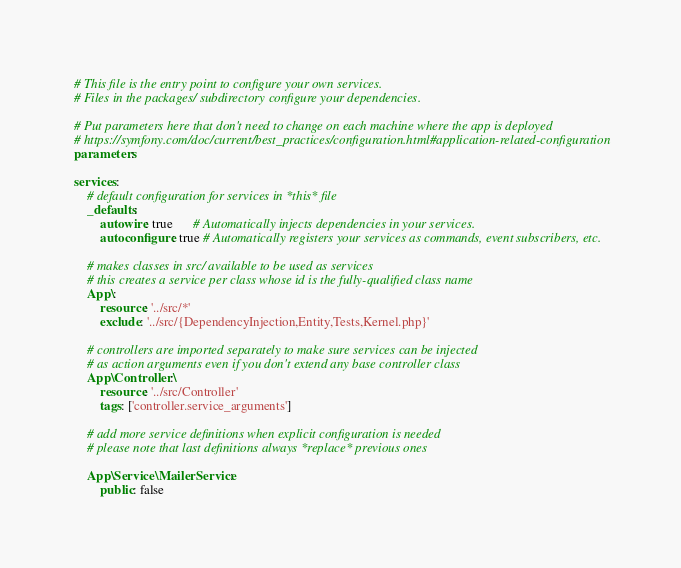<code> <loc_0><loc_0><loc_500><loc_500><_YAML_># This file is the entry point to configure your own services.
# Files in the packages/ subdirectory configure your dependencies.

# Put parameters here that don't need to change on each machine where the app is deployed
# https://symfony.com/doc/current/best_practices/configuration.html#application-related-configuration
parameters:

services:
    # default configuration for services in *this* file
    _defaults:
        autowire: true      # Automatically injects dependencies in your services.
        autoconfigure: true # Automatically registers your services as commands, event subscribers, etc.

    # makes classes in src/ available to be used as services
    # this creates a service per class whose id is the fully-qualified class name
    App\:
        resource: '../src/*'
        exclude: '../src/{DependencyInjection,Entity,Tests,Kernel.php}'

    # controllers are imported separately to make sure services can be injected
    # as action arguments even if you don't extend any base controller class
    App\Controller\:
        resource: '../src/Controller'
        tags: ['controller.service_arguments']

    # add more service definitions when explicit configuration is needed
    # please note that last definitions always *replace* previous ones

    App\Service\MailerService:
        public: false</code> 